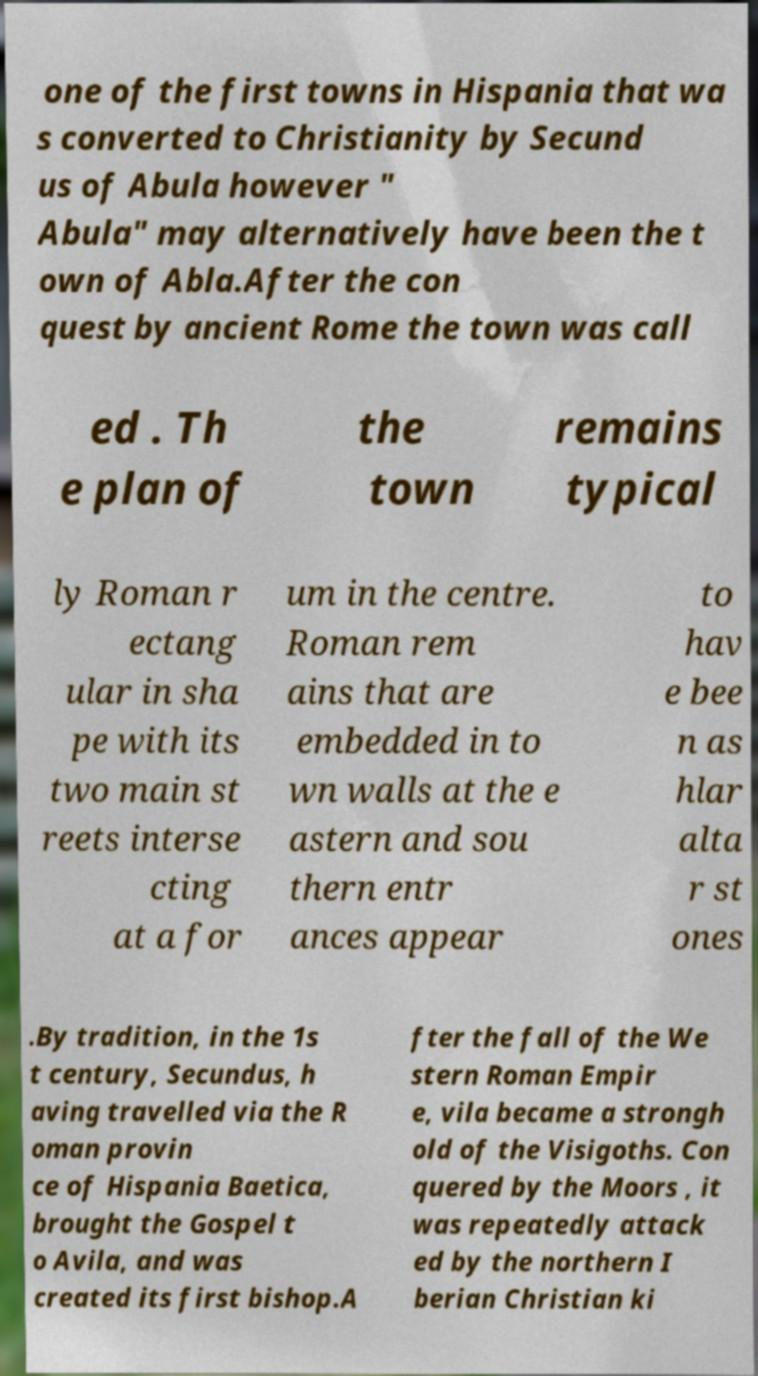Could you assist in decoding the text presented in this image and type it out clearly? one of the first towns in Hispania that wa s converted to Christianity by Secund us of Abula however " Abula" may alternatively have been the t own of Abla.After the con quest by ancient Rome the town was call ed . Th e plan of the town remains typical ly Roman r ectang ular in sha pe with its two main st reets interse cting at a for um in the centre. Roman rem ains that are embedded in to wn walls at the e astern and sou thern entr ances appear to hav e bee n as hlar alta r st ones .By tradition, in the 1s t century, Secundus, h aving travelled via the R oman provin ce of Hispania Baetica, brought the Gospel t o Avila, and was created its first bishop.A fter the fall of the We stern Roman Empir e, vila became a strongh old of the Visigoths. Con quered by the Moors , it was repeatedly attack ed by the northern I berian Christian ki 